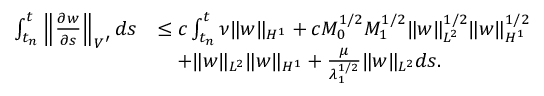<formula> <loc_0><loc_0><loc_500><loc_500>\begin{array} { r l } { \int _ { t _ { n } } ^ { t } \left \| \frac { \partial w } { \partial s } \right \| _ { V ^ { \prime } } d s } & { \leq c \int _ { t _ { n } } ^ { t } \nu \| w \| _ { H ^ { 1 } } + c M _ { 0 } ^ { 1 / 2 } M _ { 1 } ^ { 1 / 2 } \| w \| _ { L ^ { 2 } } ^ { 1 / 2 } \| w \| _ { H ^ { 1 } } ^ { 1 / 2 } } \\ & { \quad + \| w \| _ { L ^ { 2 } } \| w \| _ { H ^ { 1 } } + \frac { \mu } { \lambda _ { 1 } ^ { 1 / 2 } } \| w \| _ { L ^ { 2 } } d s . } \end{array}</formula> 